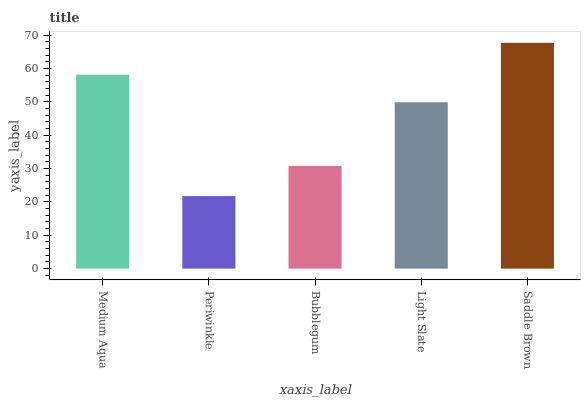Is Bubblegum the minimum?
Answer yes or no. No. Is Bubblegum the maximum?
Answer yes or no. No. Is Bubblegum greater than Periwinkle?
Answer yes or no. Yes. Is Periwinkle less than Bubblegum?
Answer yes or no. Yes. Is Periwinkle greater than Bubblegum?
Answer yes or no. No. Is Bubblegum less than Periwinkle?
Answer yes or no. No. Is Light Slate the high median?
Answer yes or no. Yes. Is Light Slate the low median?
Answer yes or no. Yes. Is Periwinkle the high median?
Answer yes or no. No. Is Saddle Brown the low median?
Answer yes or no. No. 